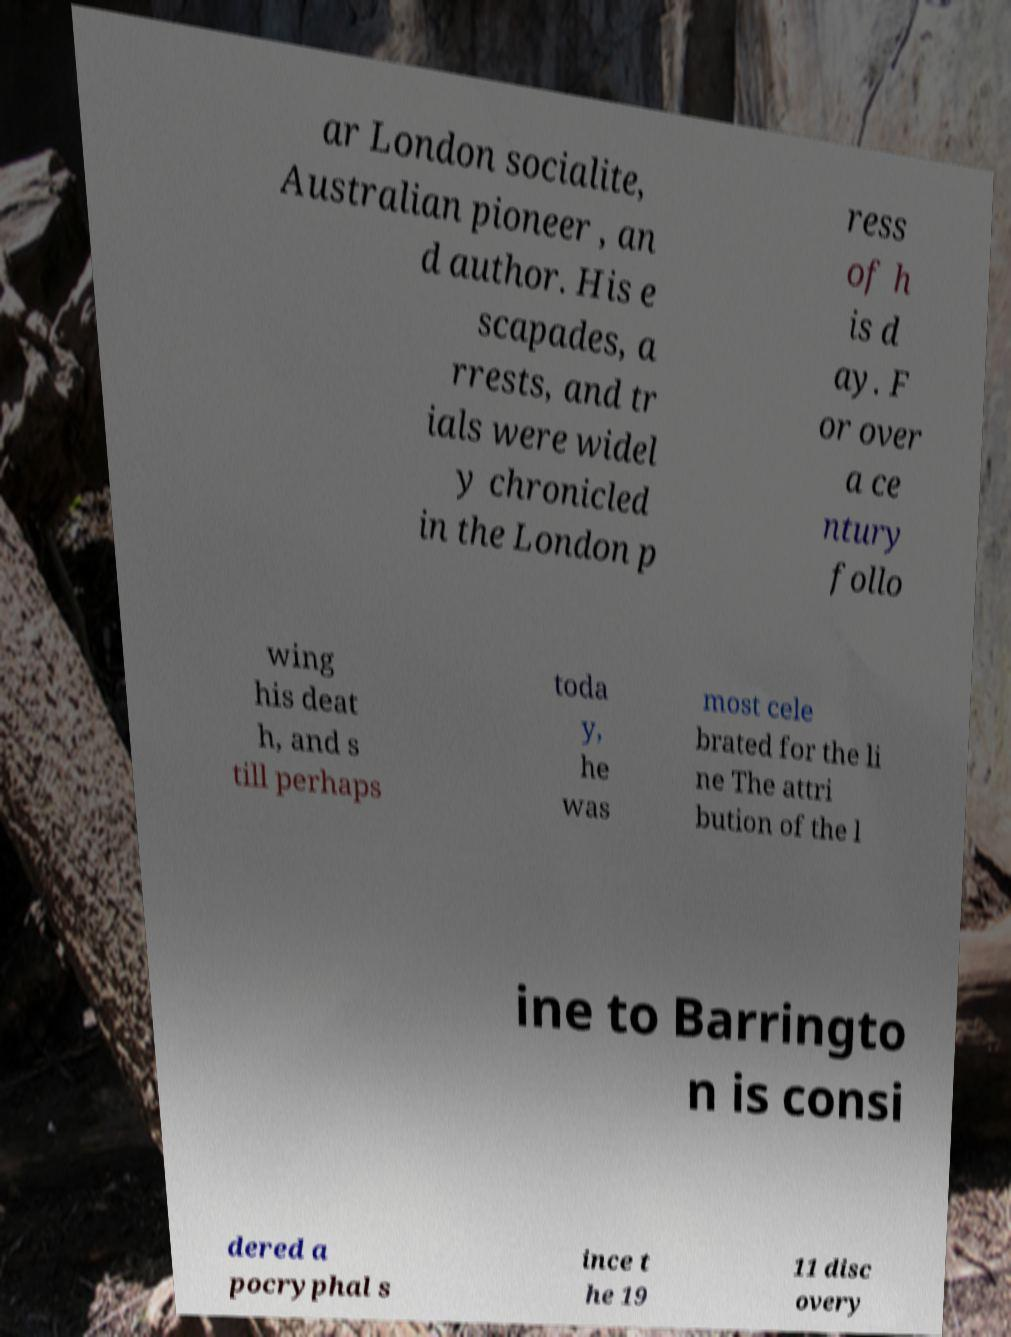Please read and relay the text visible in this image. What does it say? ar London socialite, Australian pioneer , an d author. His e scapades, a rrests, and tr ials were widel y chronicled in the London p ress of h is d ay. F or over a ce ntury follo wing his deat h, and s till perhaps toda y, he was most cele brated for the li ne The attri bution of the l ine to Barringto n is consi dered a pocryphal s ince t he 19 11 disc overy 